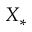<formula> <loc_0><loc_0><loc_500><loc_500>X _ { * }</formula> 